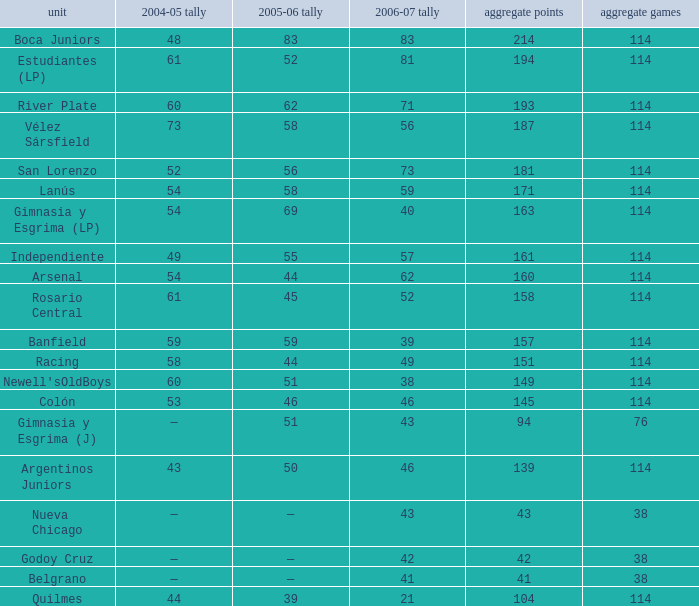What is the average total pld with 45 points in 2005-06, and more than 52 points in 2006-07? None. 